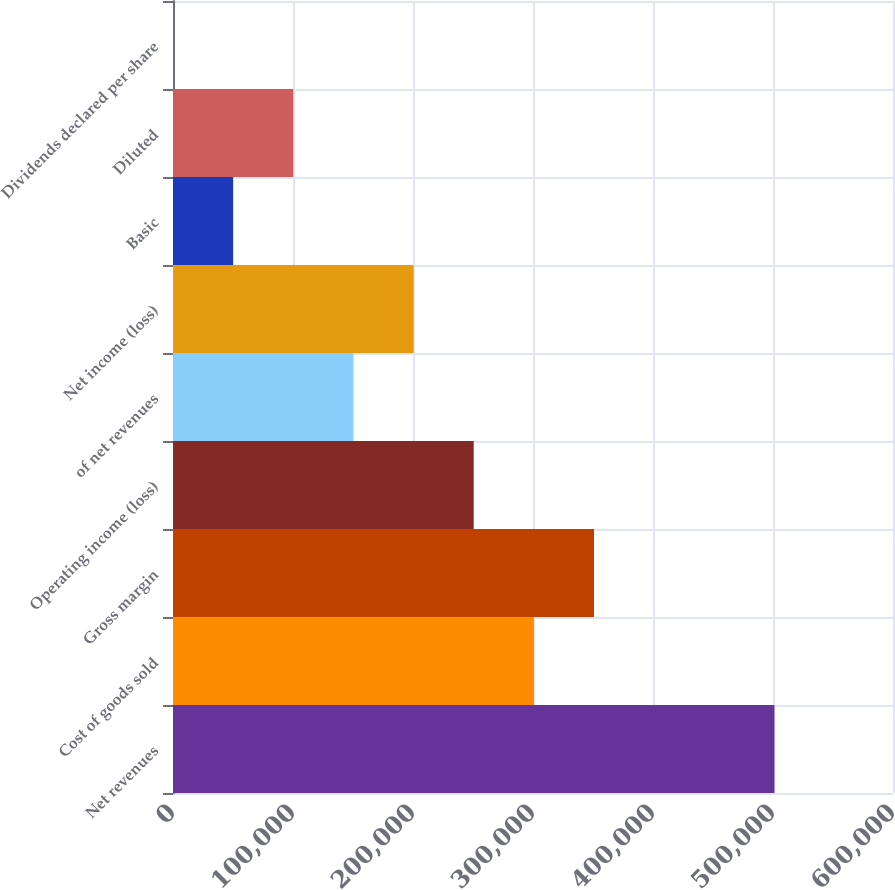<chart> <loc_0><loc_0><loc_500><loc_500><bar_chart><fcel>Net revenues<fcel>Cost of goods sold<fcel>Gross margin<fcel>Operating income (loss)<fcel>of net revenues<fcel>Net income (loss)<fcel>Basic<fcel>Diluted<fcel>Dividends declared per share<nl><fcel>501204<fcel>300722<fcel>350843<fcel>250602<fcel>150361<fcel>200482<fcel>50120.6<fcel>100241<fcel>0.2<nl></chart> 